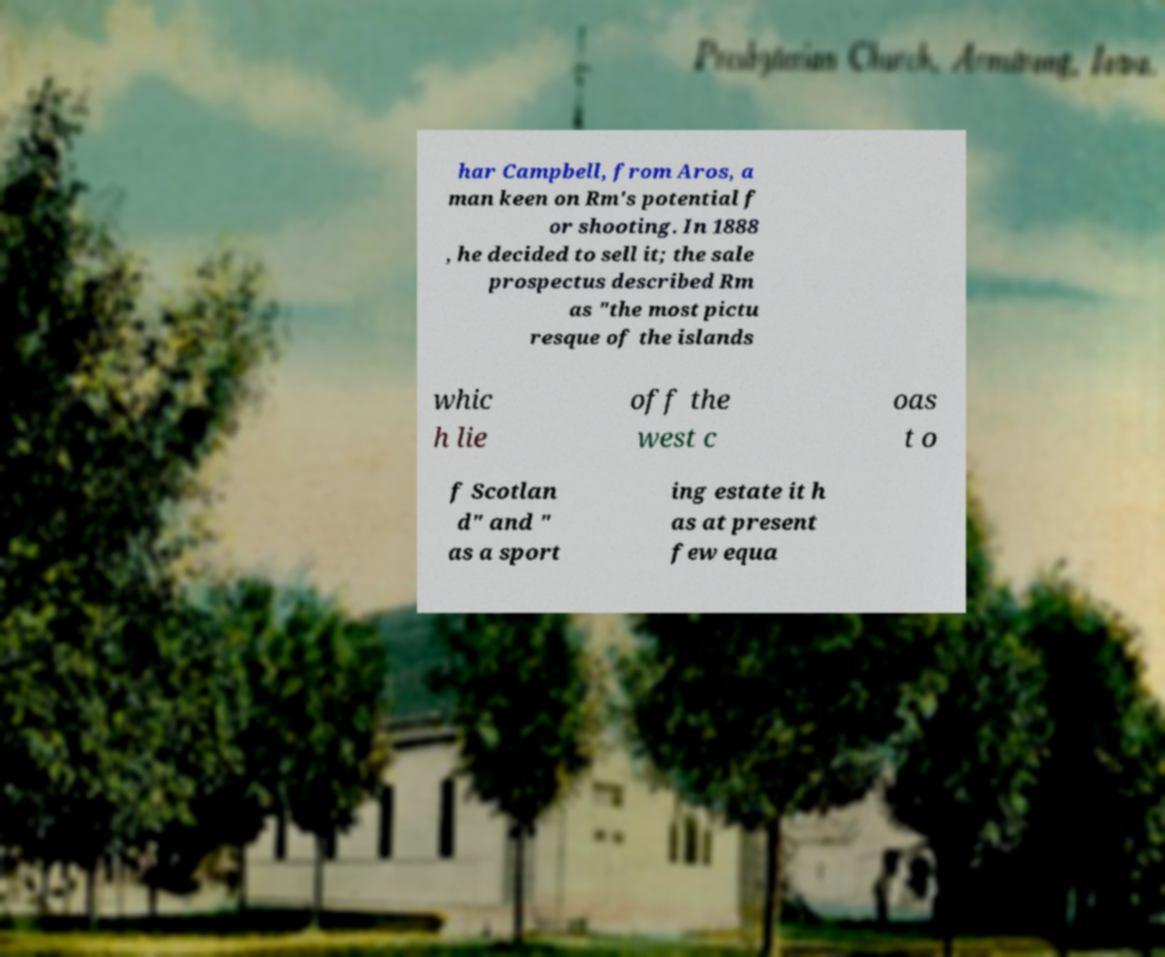Can you read and provide the text displayed in the image?This photo seems to have some interesting text. Can you extract and type it out for me? har Campbell, from Aros, a man keen on Rm's potential f or shooting. In 1888 , he decided to sell it; the sale prospectus described Rm as "the most pictu resque of the islands whic h lie off the west c oas t o f Scotlan d" and " as a sport ing estate it h as at present few equa 